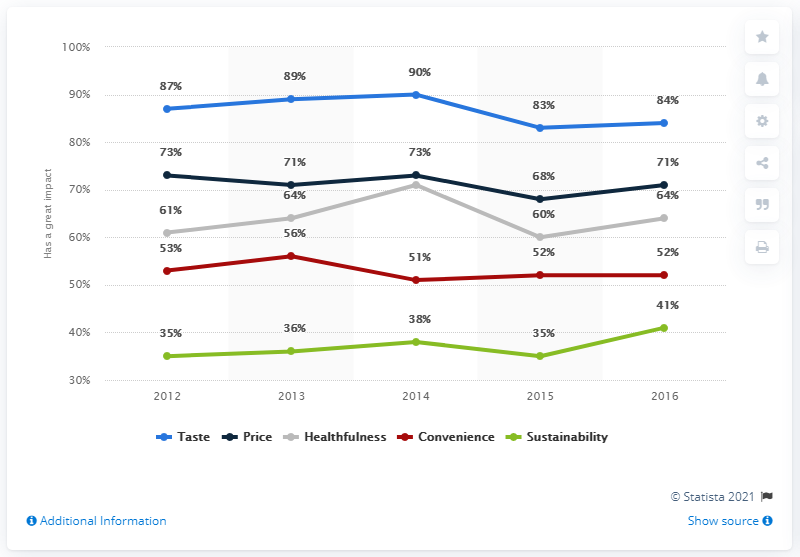Give some essential details in this illustration. In 2012, 73% of respondents reported that the price of food and beverages played a role in their buying decision. 